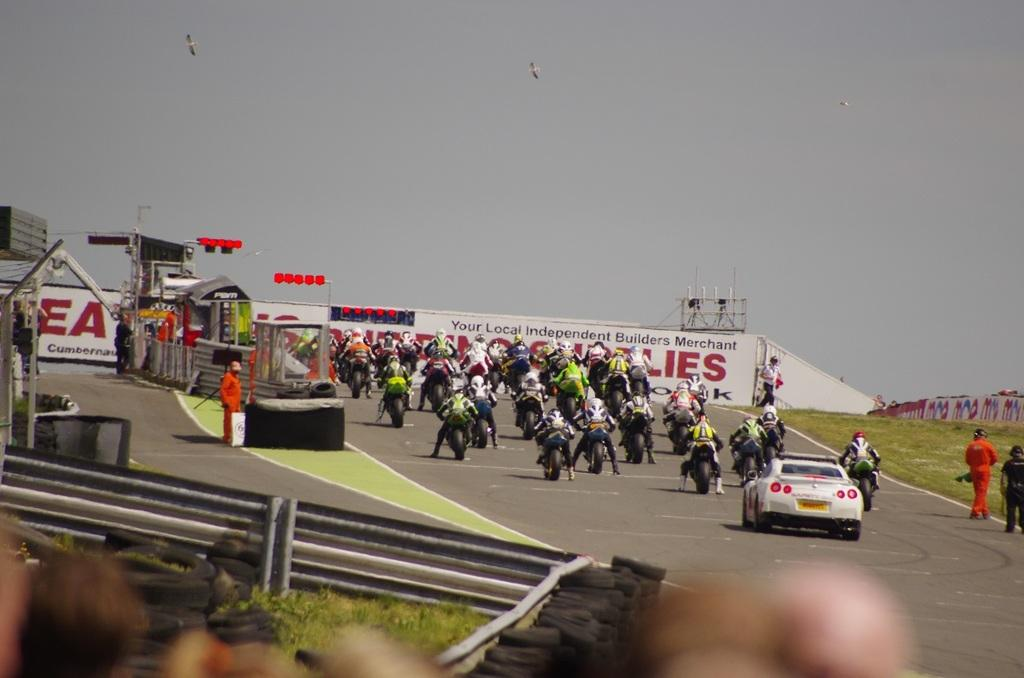<image>
Offer a succinct explanation of the picture presented. A motorcycle race is preparing to begin sponsored by Your Local independent Builders Merchant. 